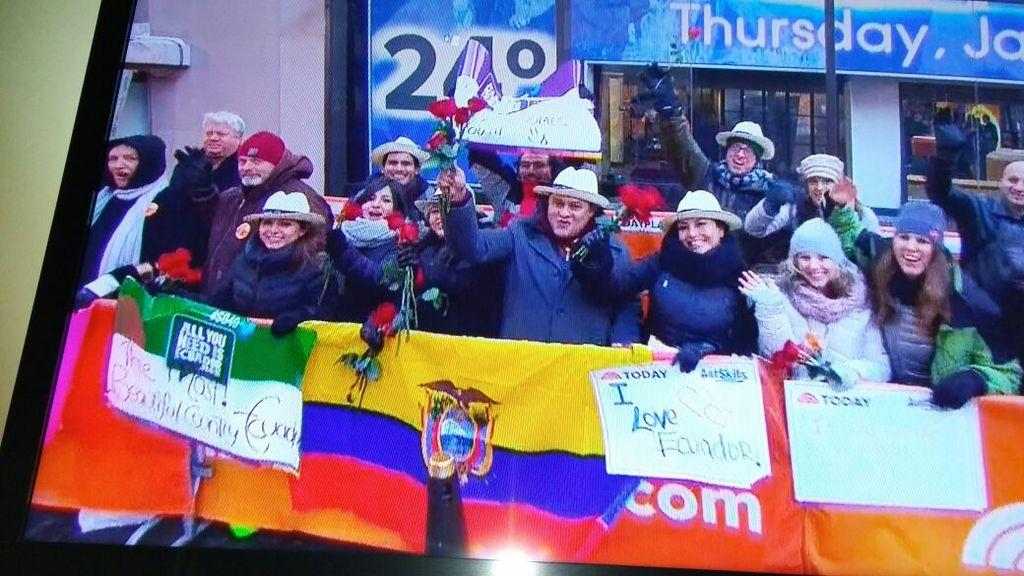What is the source of the image? The image is taken from a photo frame. What are the main subjects in the image? There are persons in the middle of the image. What are the persons holding in the image? The persons are holding banners and one of them is holding flowers. What can be seen in the background of the image? There is a store visible in the background. What type of berry is being taught by the person in the image? There is no berry or teaching activity present in the image. How does the person holding flowers express anger in the image? There is no indication of anger in the image; the person holding flowers appears to be participating in a peaceful event. 